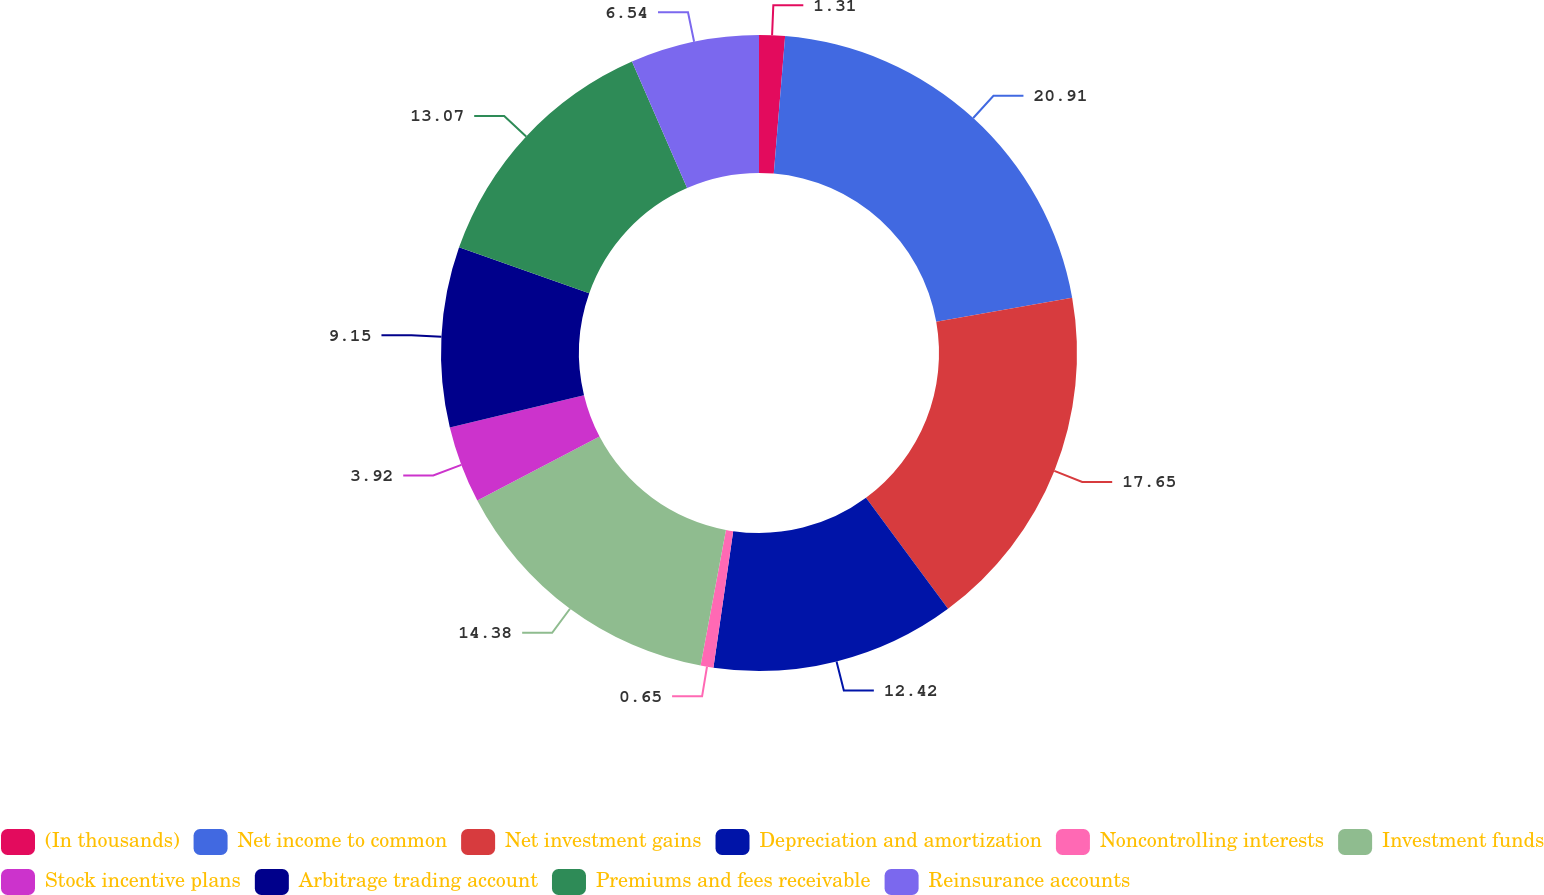<chart> <loc_0><loc_0><loc_500><loc_500><pie_chart><fcel>(In thousands)<fcel>Net income to common<fcel>Net investment gains<fcel>Depreciation and amortization<fcel>Noncontrolling interests<fcel>Investment funds<fcel>Stock incentive plans<fcel>Arbitrage trading account<fcel>Premiums and fees receivable<fcel>Reinsurance accounts<nl><fcel>1.31%<fcel>20.91%<fcel>17.65%<fcel>12.42%<fcel>0.65%<fcel>14.38%<fcel>3.92%<fcel>9.15%<fcel>13.07%<fcel>6.54%<nl></chart> 